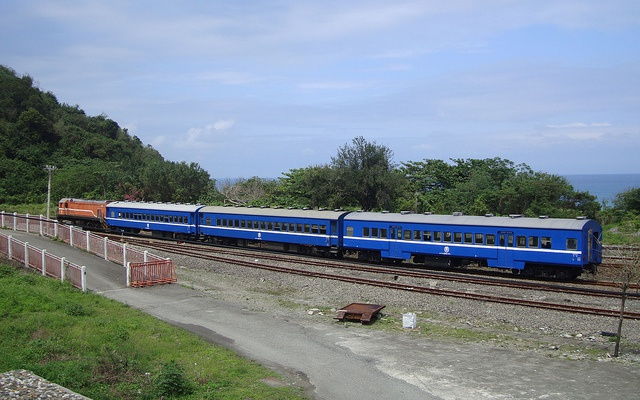Describe the objects in this image and their specific colors. I can see a train in darkgray, blue, black, and navy tones in this image. 